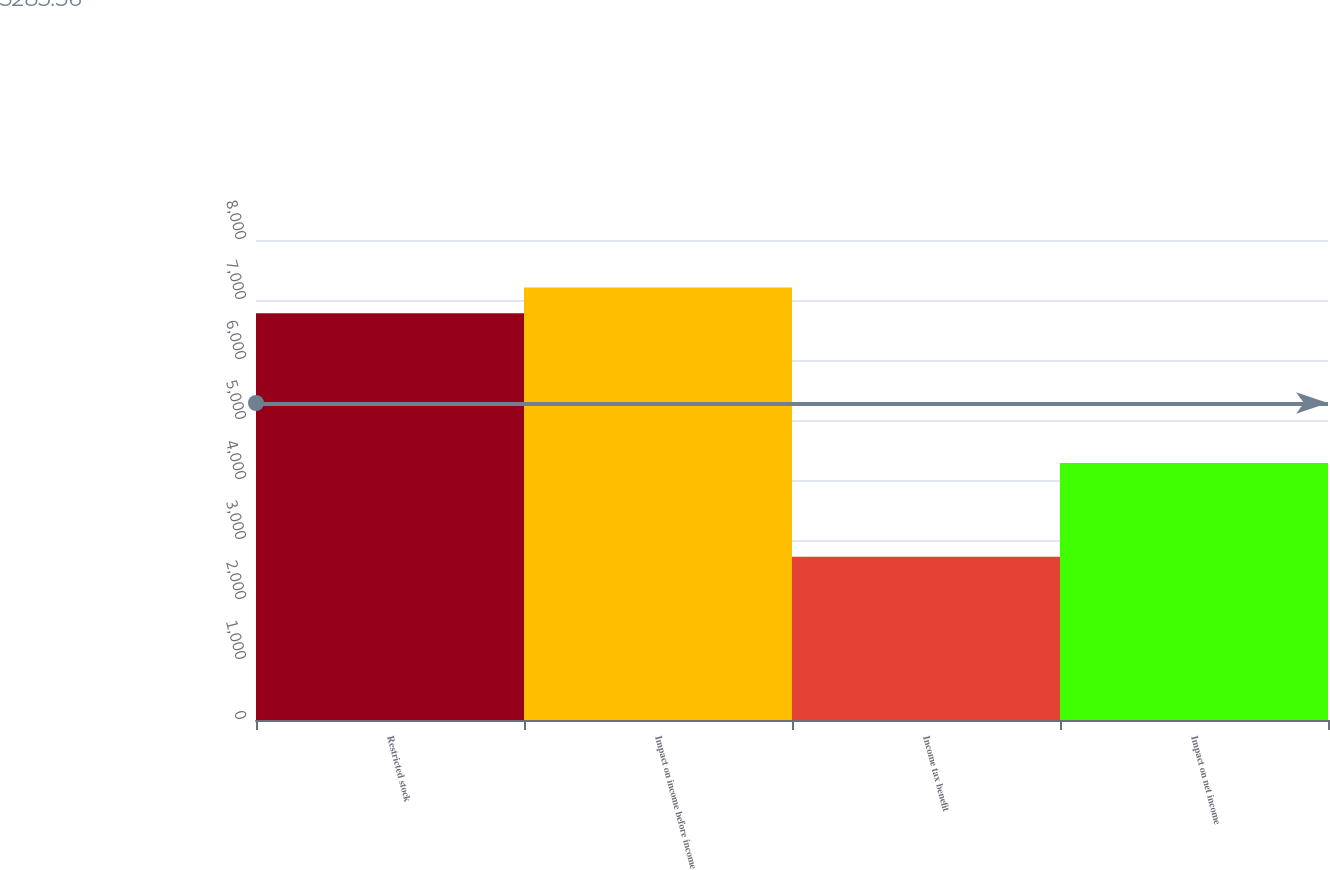Convert chart. <chart><loc_0><loc_0><loc_500><loc_500><bar_chart><fcel>Restricted stock<fcel>Impact on income before income<fcel>Income tax benefit<fcel>Impact on net income<nl><fcel>6780<fcel>7208.5<fcel>2721<fcel>4285<nl></chart> 